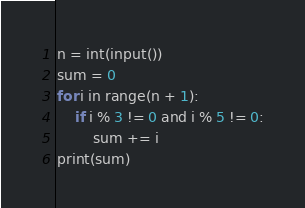Convert code to text. <code><loc_0><loc_0><loc_500><loc_500><_Python_>n = int(input())
sum = 0
for i in range(n + 1):
    if i % 3 != 0 and i % 5 != 0:
        sum += i
print(sum)</code> 